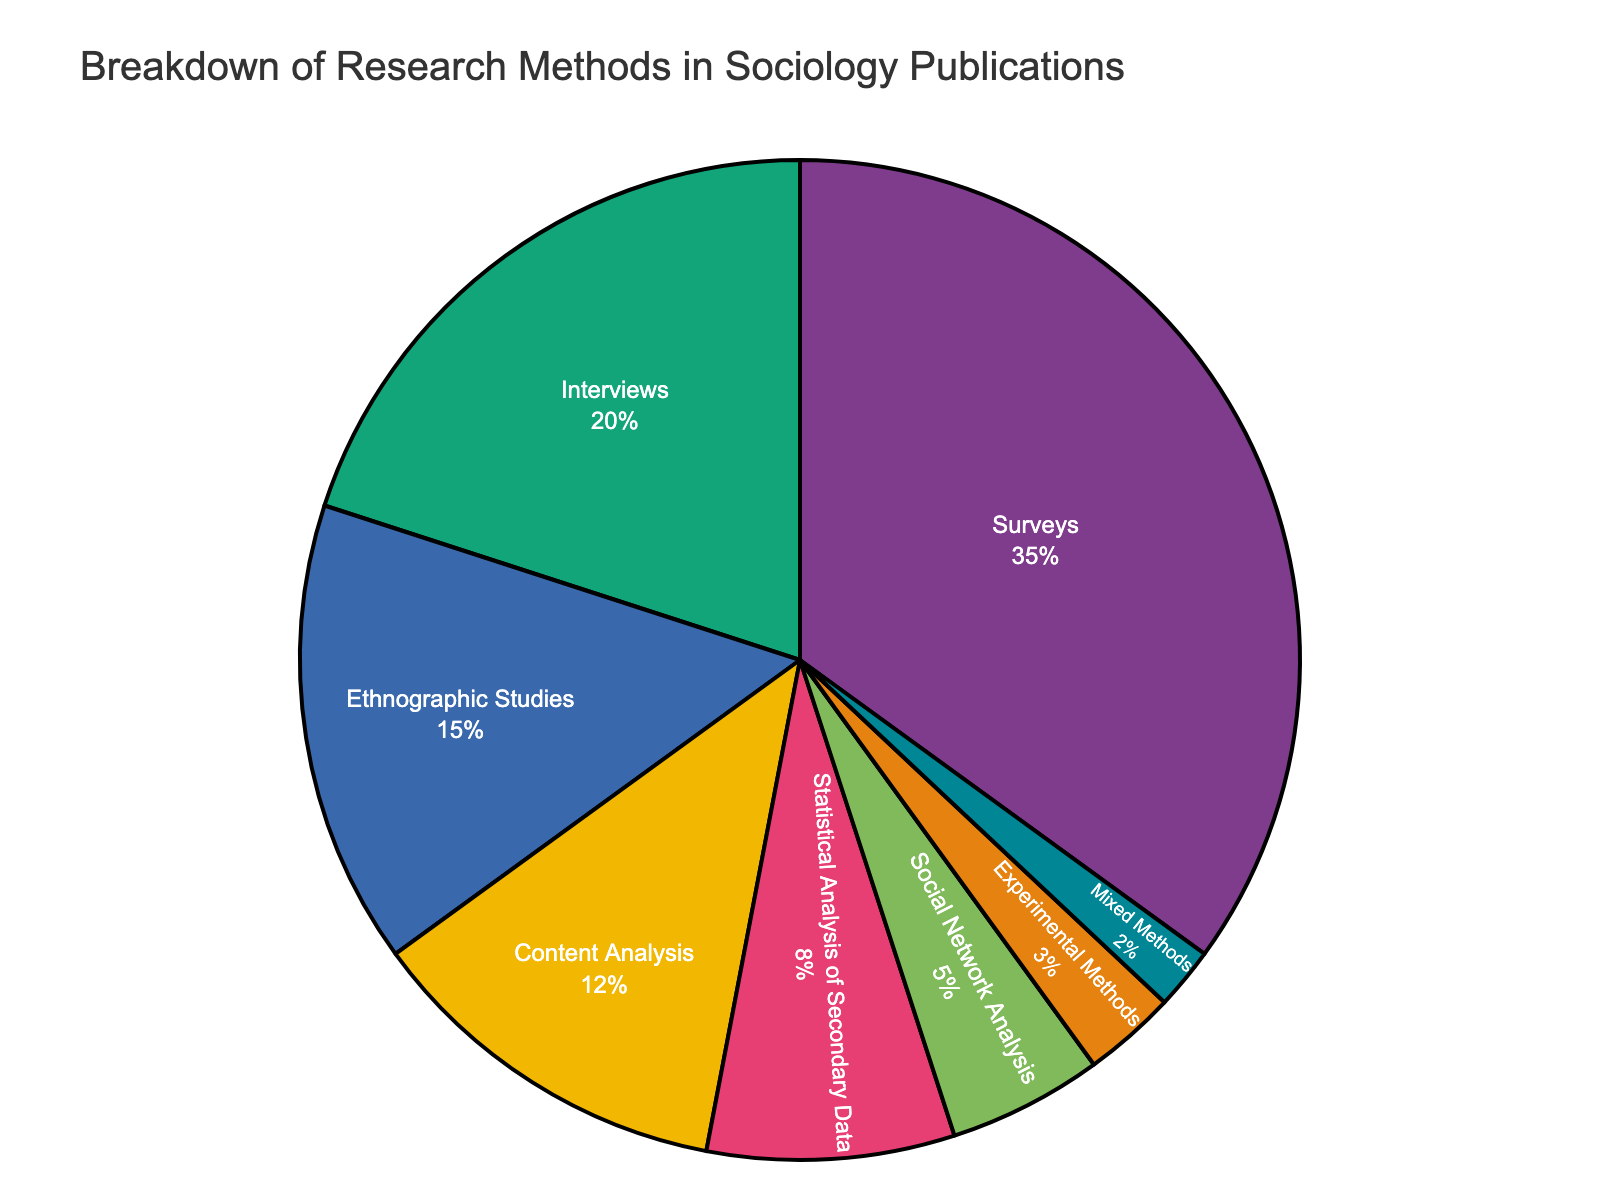What's the most frequently employed research method according to the pie chart? The wording "most frequently" indicates looking for the largest section of the pie chart by percentage. According to the data, Surveys have the highest percentage at 35%.
Answer: Surveys Which research method is the least common? The least common method would be the one with the smallest percentage in the pie chart. According to the data, Mixed Methods has the lowest percentage at 2%.
Answer: Mixed Methods How much more common are Surveys compared to Interviews? To find out how much more common Surveys are compared to Interviews, subtract the percentage of Interviews from that of Surveys. That is 35% - 20% = 15%.
Answer: 15% What is the combined percentage for symbolic methods like Social Network Analysis and Experimental Methods? Add the percentages for Social Network Analysis and Experimental Methods. That is 5% + 3% = 8%.
Answer: 8% Rank the top three research methods by percentage employed. To rank, sort the methods by their percentages. The top three are Surveys (35%), Interviews (20%), and Ethnographic Studies (15%).
Answer: Surveys, Interviews, Ethnographic Studies What fraction of the total percentage do Content Analysis and Statistical Analysis of Secondary Data together represent? Add the percentages for both Content Analysis and Statistical Analysis of Secondary Data. That is 12% + 8% = 20%.
Answer: 20% If you combine the percentages of all methods except Surveys, would it be more than 50%? Add the percentages for all methods except Surveys to see if they sum up to more than 50%. The calculation is Interviews (20%) + Ethnographic Studies (15%) + Content Analysis (12%) + Statistical Analysis of Secondary Data (8%) + Social Network Analysis (5%) + Experimental Methods (3%) + Mixed Methods (2%) = 65%
Answer: Yes What is the total percentage represented by qualitative methods (Interviews, Ethnographic Studies, Content Analysis)? Add the percentages: Interviews (20%) + Ethnographic Studies (15%) + Content Analysis (12%) = 47%.
Answer: 47% Is the combined percentage of Statistical Analysis of Secondary Data and Social Network Analysis greater than the percentage of Ethnographic Studies? Add the percentages of Statistical Analysis of Secondary Data (8%) and Social Network Analysis (5%) and compare to that of Ethnographic Studies (15%). The combined percentage is 13%, which is less than 15%.
Answer: No If you were to group the methods into qualitative (Interviews, Ethnographic Studies, Content Analysis) and quantitative (Surveys, Statistical Analysis of Secondary Data, Social Network Analysis, Experimental Methods), which group has a higher total percentage and by how much? Add the percentages for each group. Qualitative: 20% (Interviews) + 15% (Ethnographic Studies) + 12% (Content Analysis) = 47%. Quantitative: 35% (Surveys) + 8% (Statistical Analysis of Secondary Data) + 5% (Social Network Analysis) + 3% (Experimental Methods) = 51%. Quantitative percentage is higher. Difference: 51% - 47% = 4%.
Answer: Quantitative, by 4% 